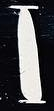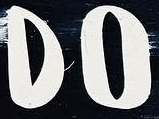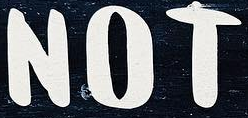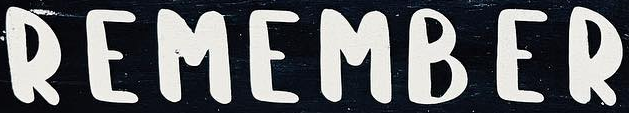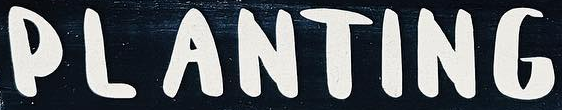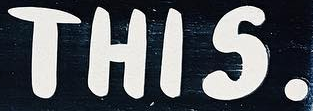What words can you see in these images in sequence, separated by a semicolon? I; DO; NOT; REMAMBER; PLANTING; THIS. 